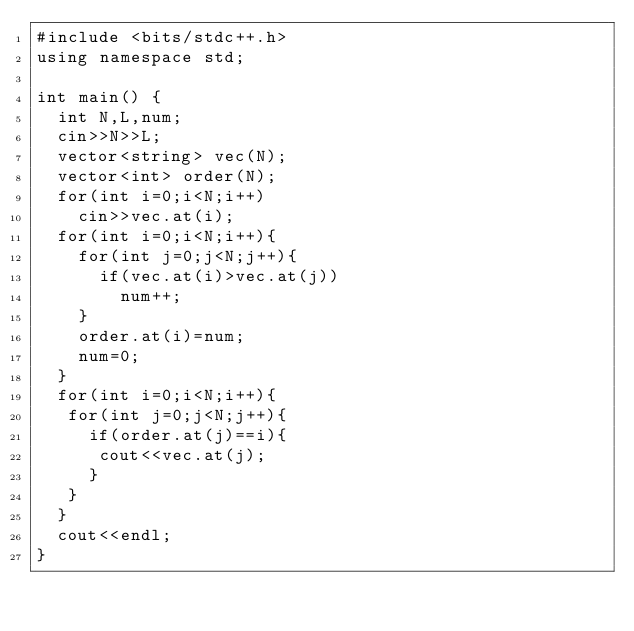Convert code to text. <code><loc_0><loc_0><loc_500><loc_500><_C++_>#include <bits/stdc++.h>
using namespace std;
 
int main() {
  int N,L,num;
  cin>>N>>L;
  vector<string> vec(N);
  vector<int> order(N);
  for(int i=0;i<N;i++)
    cin>>vec.at(i);
  for(int i=0;i<N;i++){
    for(int j=0;j<N;j++){
      if(vec.at(i)>vec.at(j))
        num++;
    }
    order.at(i)=num;
    num=0;
  }
  for(int i=0;i<N;i++){
   for(int j=0;j<N;j++){
     if(order.at(j)==i){
      cout<<vec.at(j);
     }
   }
  }
  cout<<endl;
}</code> 